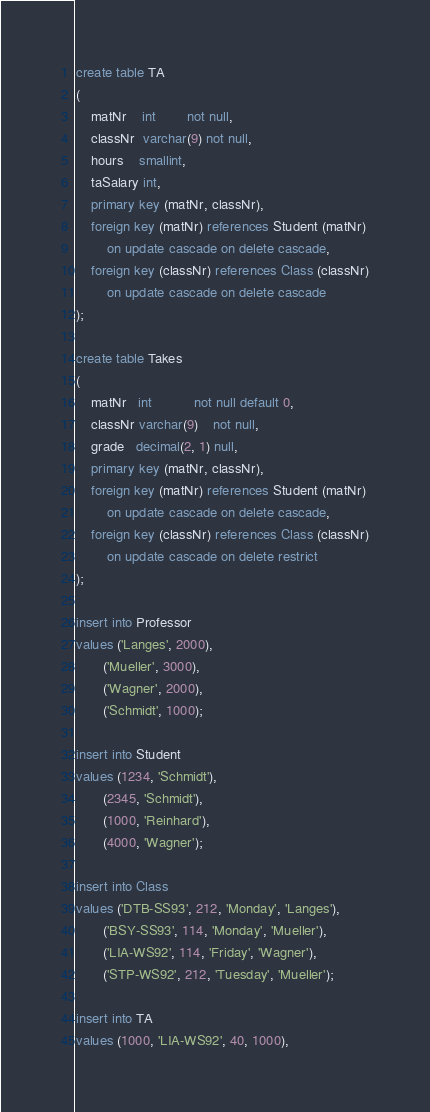<code> <loc_0><loc_0><loc_500><loc_500><_SQL_>create table TA
(
    matNr    int        not null,
    classNr  varchar(9) not null,
    hours    smallint,
    taSalary int,
    primary key (matNr, classNr),
    foreign key (matNr) references Student (matNr)
        on update cascade on delete cascade,
    foreign key (classNr) references Class (classNr)
        on update cascade on delete cascade
);

create table Takes
(
    matNr   int           not null default 0,
    classNr varchar(9)    not null,
    grade   decimal(2, 1) null,
    primary key (matNr, classNr),
    foreign key (matNr) references Student (matNr)
        on update cascade on delete cascade,
    foreign key (classNr) references Class (classNr)
        on update cascade on delete restrict
);

insert into Professor
values ('Langes', 2000),
       ('Mueller', 3000),
       ('Wagner', 2000),
       ('Schmidt', 1000);

insert into Student
values (1234, 'Schmidt'),
       (2345, 'Schmidt'),
       (1000, 'Reinhard'),
       (4000, 'Wagner');

insert into Class
values ('DTB-SS93', 212, 'Monday', 'Langes'),
       ('BSY-SS93', 114, 'Monday', 'Mueller'),
       ('LIA-WS92', 114, 'Friday', 'Wagner'),
       ('STP-WS92', 212, 'Tuesday', 'Mueller');

insert into TA
values (1000, 'LIA-WS92', 40, 1000),</code> 